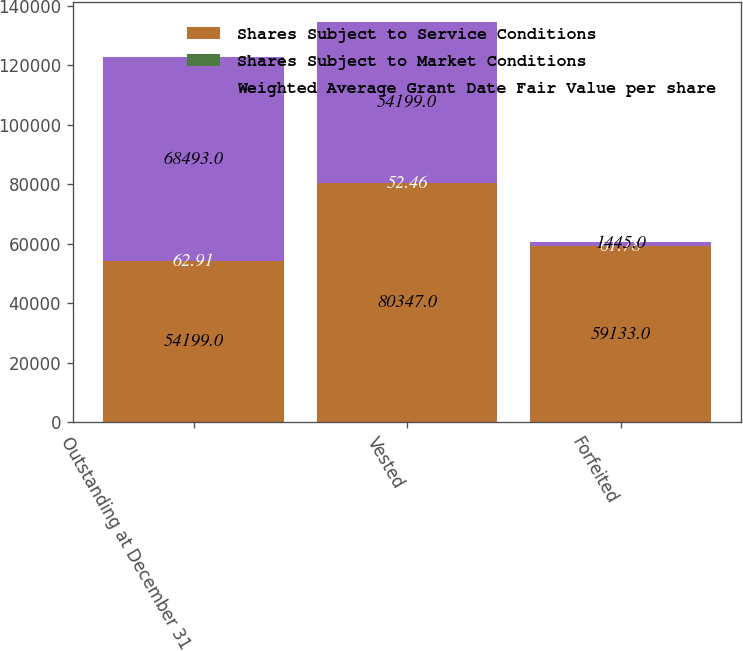<chart> <loc_0><loc_0><loc_500><loc_500><stacked_bar_chart><ecel><fcel>Outstanding at December 31<fcel>Vested<fcel>Forfeited<nl><fcel>Shares Subject to Service Conditions<fcel>54199<fcel>80347<fcel>59133<nl><fcel>Shares Subject to Market Conditions<fcel>62.91<fcel>52.46<fcel>61.78<nl><fcel>Weighted Average Grant Date Fair Value per share<fcel>68493<fcel>54199<fcel>1445<nl></chart> 